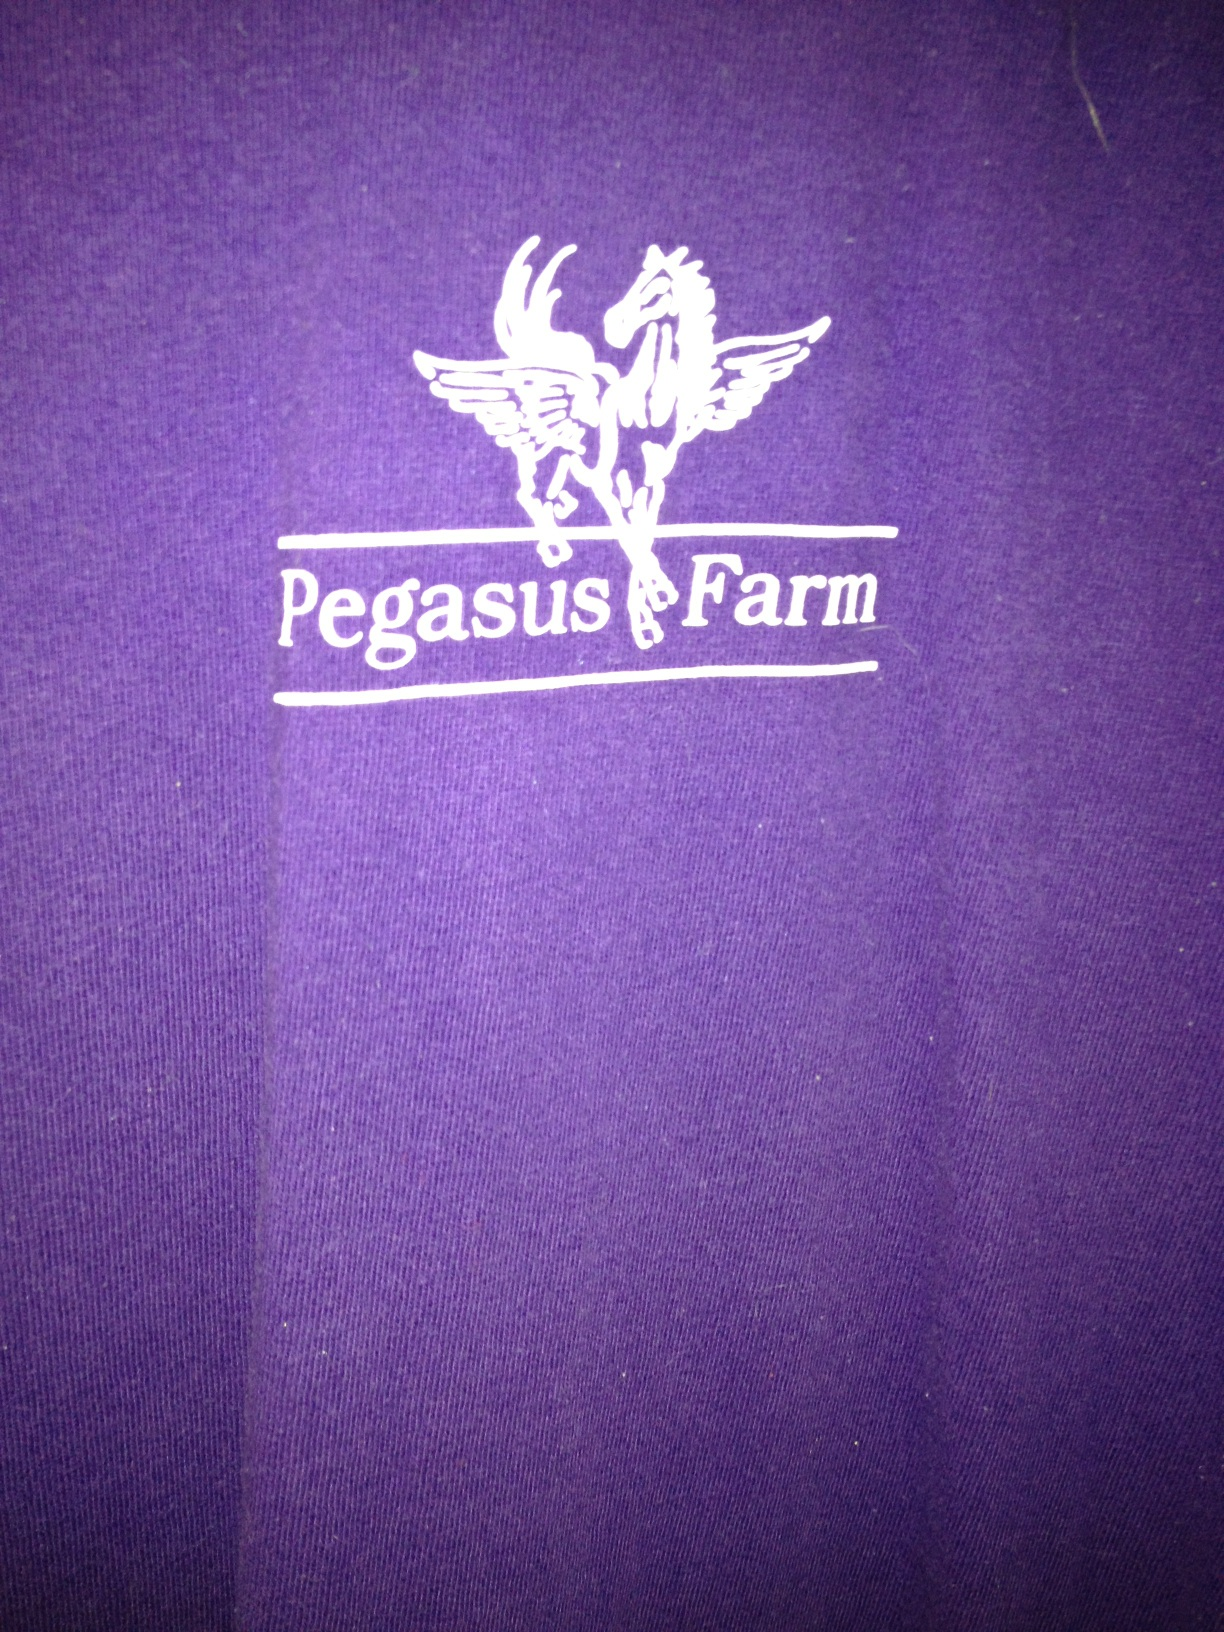I'm thinking of wearing this shirt to a casual event. Does it seem suitable? Absolutely! The vibrant purple color and the distinctive logo make it a great choice for a casual setting. It's eye-catching yet relaxed, perfect for an event where you'd like to be comfortable while also expressing a bit of personality. 